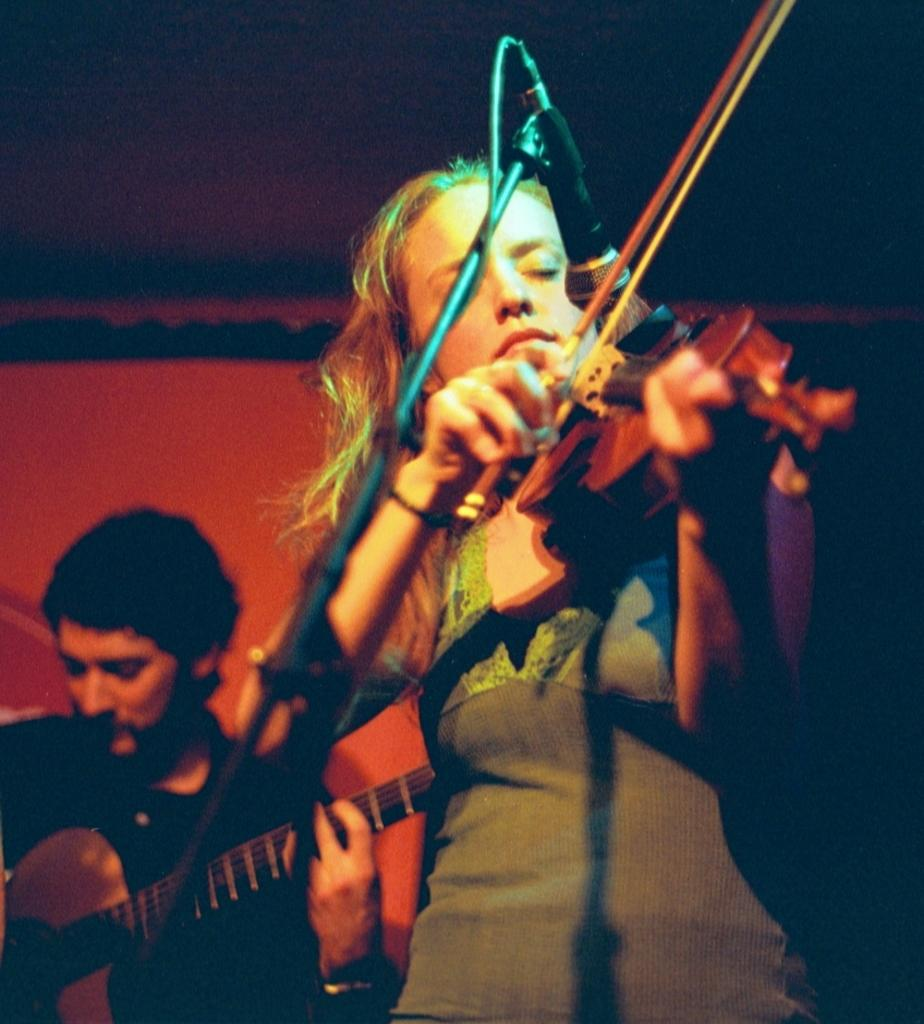What is the woman in the image doing? The woman is playing the violin in the image. What is the woman standing near in the image? There is a microphone in front of the woman. What is the man in the image doing? The man is playing the guitar in the image. What type of discovery was made using a quarter and a dime in the image? There is no mention of a quarter or a dime in the image, and therefore no such discovery can be observed. 